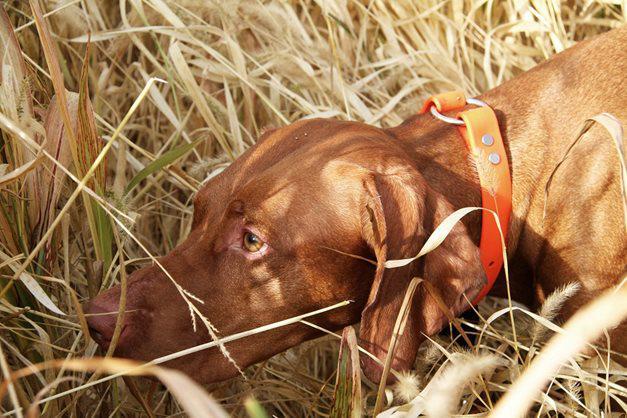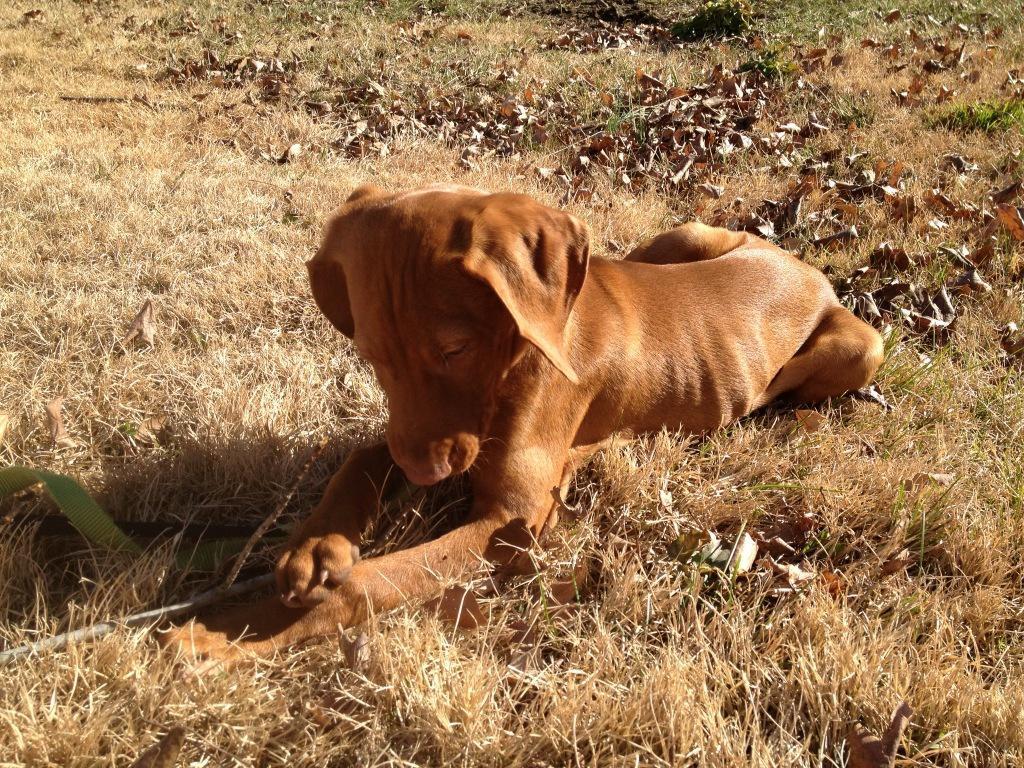The first image is the image on the left, the second image is the image on the right. For the images displayed, is the sentence "In at least one image there is a shotgun behind a dog with his tongue stuck out." factually correct? Answer yes or no. No. The first image is the image on the left, the second image is the image on the right. For the images shown, is this caption "A dog is laying down." true? Answer yes or no. Yes. 